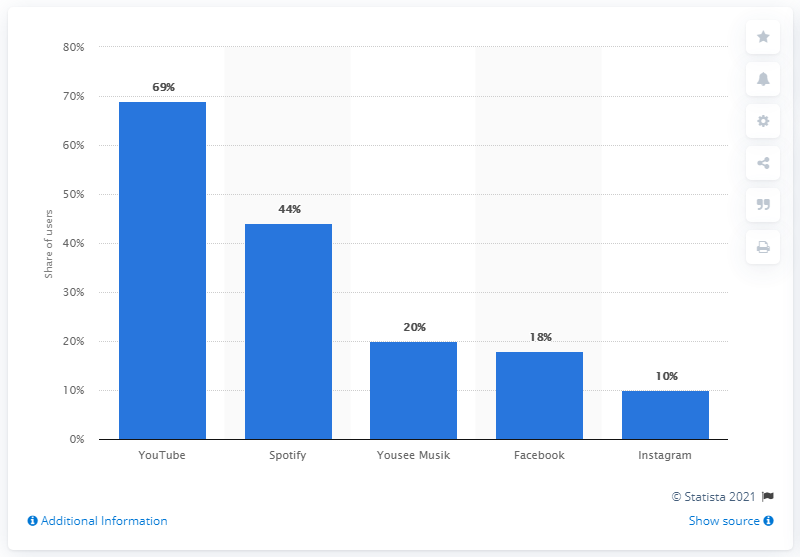Specify some key components in this picture. According to available data, YouTube is the most popular digital music service in Denmark. 